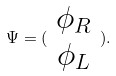<formula> <loc_0><loc_0><loc_500><loc_500>\Psi = ( \begin{array} { c } \phi _ { R } \\ \phi _ { L } \end{array} ) .</formula> 